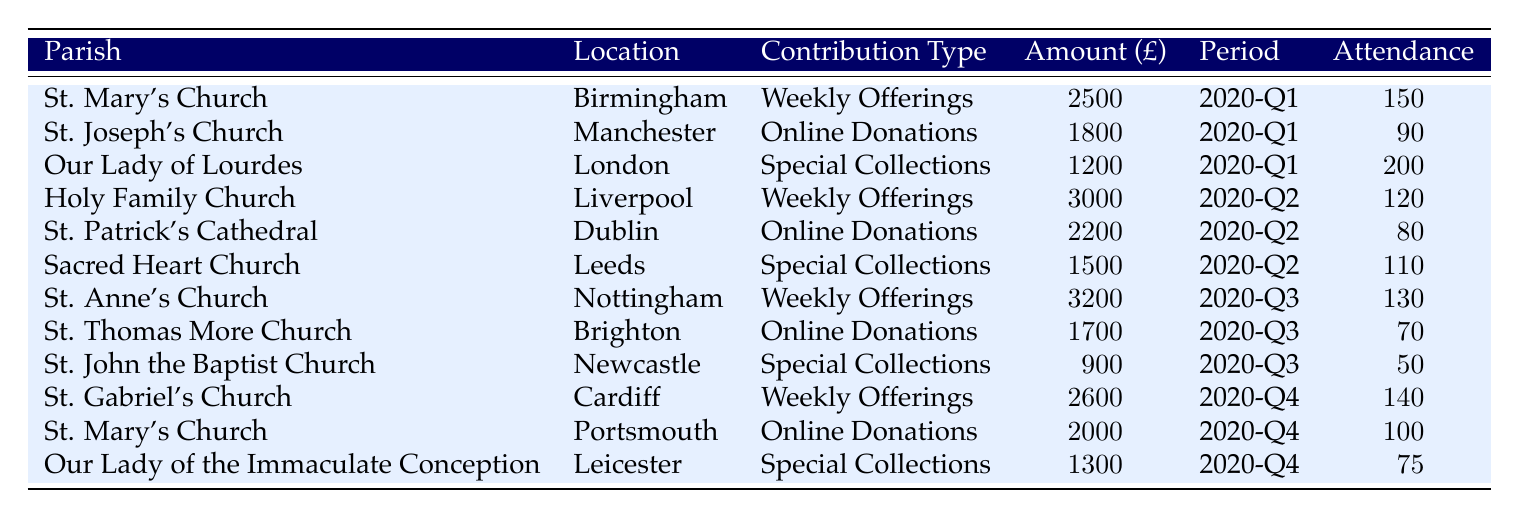What was the total amount contributed by St. Mary’s Church, Birmingham during the pandemic? The table shows that St. Mary’s Church contributed £2,500 in the pandemic period of 2020-Q1. Therefore, the total contribution is simply this amount.
Answer: £2,500 Which parish had the highest attendance during the pandemic? By reviewing the attendance column, St. Our Lady of Lourdes, London shows the highest attendance with 200 people during 2020-Q1.
Answer: 200 Did any parish receive more than £3,000 in contributions? Looking through the amounts contributed, there is no entry with more than £3,000. The highest contribution listed is £3,200 from St. Anne’s Church in 2020-Q3, but does not exceed £3,000.
Answer: No What was the average contribution amount in 2020-Q2? In 2020-Q2, three parishes contributed: £3,000 (Holy Family Church), £2,200 (St. Patrick’s Cathedral), and £1,500 (Sacred Heart Church). The total contribution for this period is £3,000 + £2,200 + £1,500 = £6,700. The average is £6,700 divided by 3 parishes, resulting in approximately £2,233.33.
Answer: £2,233.33 Was there a parish that only accepted Online Donations and had an attendance below 100? From the table, St. Thomas More Church, Brighton received Online Donations with an attendance of 70. Hence, this parish matches both criteria of being an online donation type and having low attendance.
Answer: Yes 